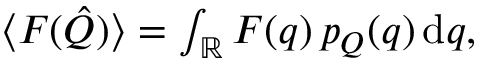<formula> <loc_0><loc_0><loc_500><loc_500>\begin{array} { r } { \langle F ( \hat { Q } ) \rangle = \int _ { \mathbb { R } } F ( q ) \, p _ { Q } ( q ) \, d q , } \end{array}</formula> 